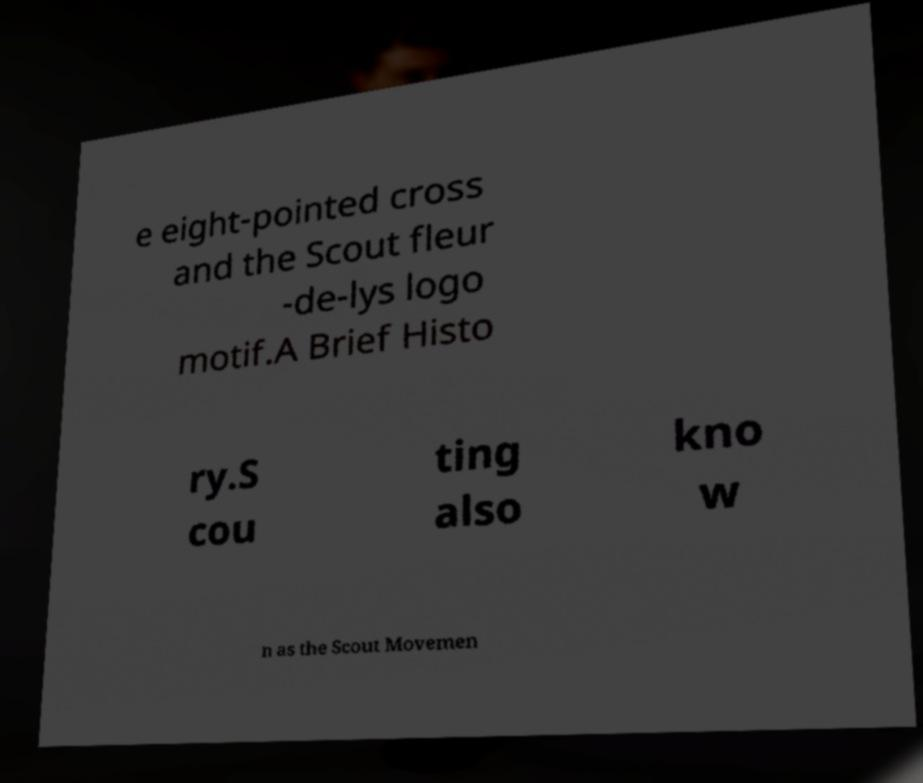There's text embedded in this image that I need extracted. Can you transcribe it verbatim? e eight-pointed cross and the Scout fleur -de-lys logo motif.A Brief Histo ry.S cou ting also kno w n as the Scout Movemen 